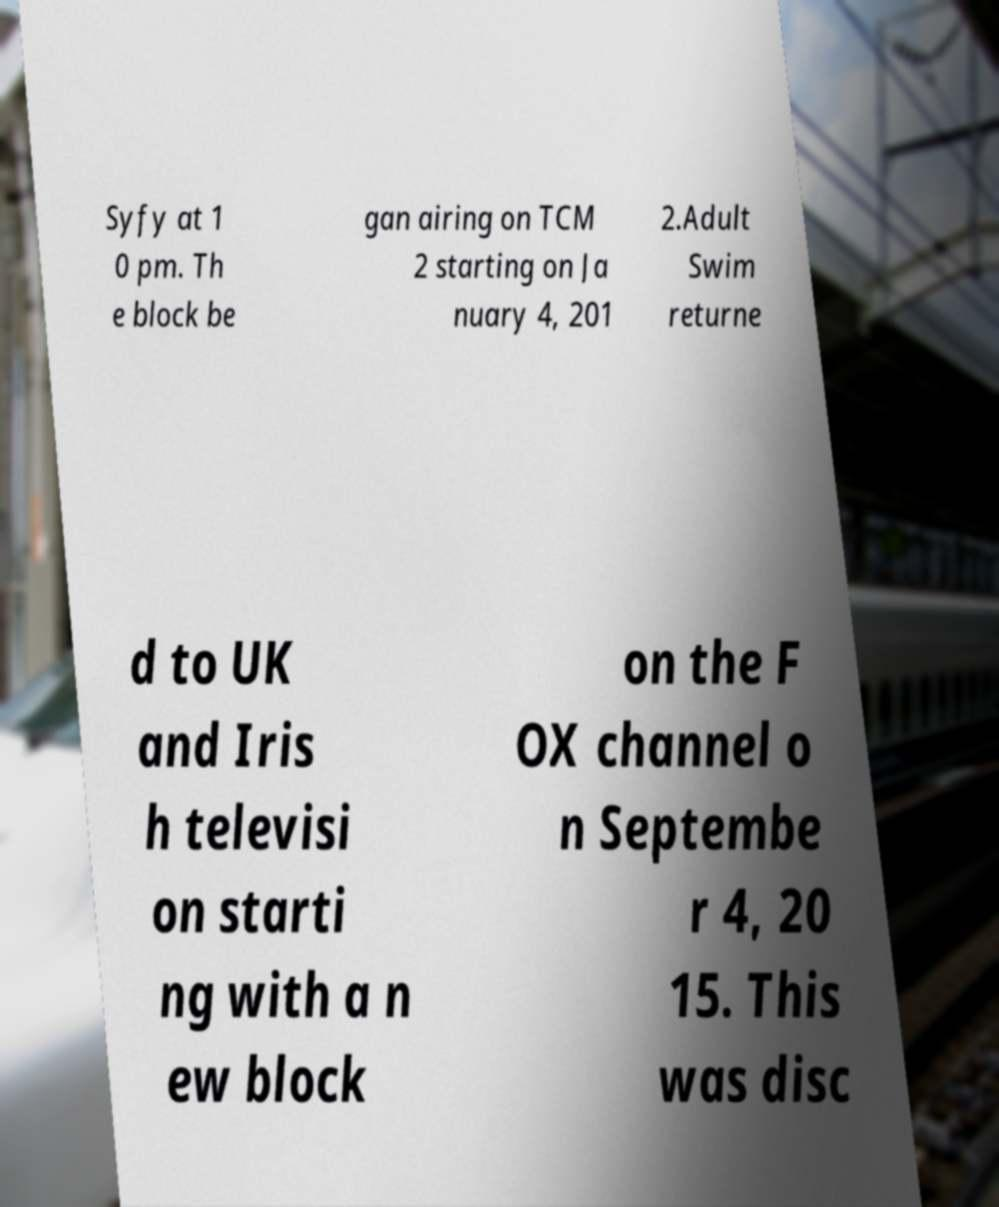There's text embedded in this image that I need extracted. Can you transcribe it verbatim? Syfy at 1 0 pm. Th e block be gan airing on TCM 2 starting on Ja nuary 4, 201 2.Adult Swim returne d to UK and Iris h televisi on starti ng with a n ew block on the F OX channel o n Septembe r 4, 20 15. This was disc 